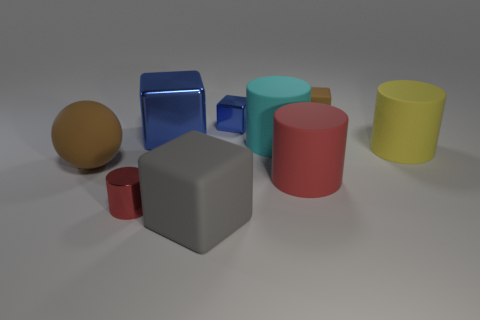Is the ball the same color as the tiny matte cube?
Ensure brevity in your answer.  Yes. There is a thing that is the same color as the sphere; what size is it?
Provide a succinct answer. Small. Is there a yellow thing that has the same material as the cyan object?
Keep it short and to the point. Yes. There is a red cylinder that is left of the big cyan cylinder; what material is it?
Your answer should be very brief. Metal. What is the material of the tiny brown object?
Give a very brief answer. Rubber. Do the red thing that is to the right of the large blue metallic block and the tiny red cylinder have the same material?
Your response must be concise. No. Are there fewer cyan rubber things behind the red shiny object than rubber spheres?
Your answer should be very brief. No. There is a rubber sphere that is the same size as the cyan rubber cylinder; what is its color?
Offer a terse response. Brown. How many big blue things are the same shape as the gray matte object?
Your response must be concise. 1. What is the color of the large matte cylinder to the right of the brown rubber cube?
Provide a succinct answer. Yellow. 